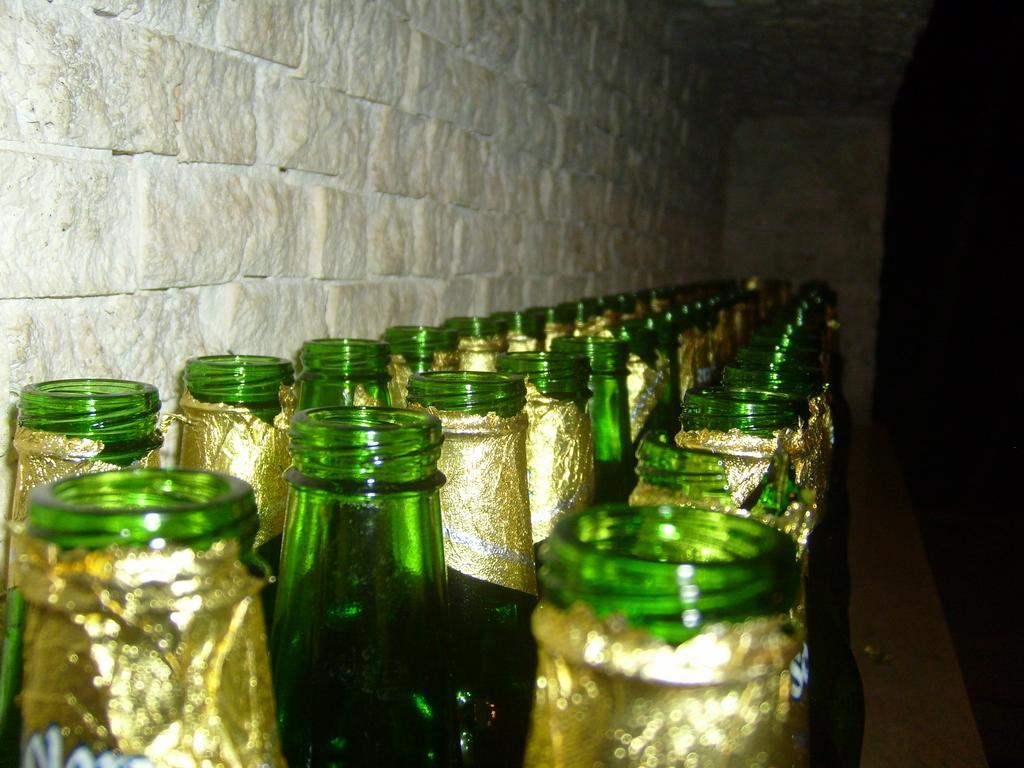Can you describe this image briefly? In this picture there are many bottles which are green in color and has a golden label on it. These bottles are arranged in three rows. There is a wall. 